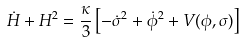<formula> <loc_0><loc_0><loc_500><loc_500>\dot { H } + H ^ { 2 } = \frac { \kappa } { 3 } \left [ - \dot { \sigma } ^ { 2 } + \dot { \phi } ^ { 2 } + V ( \phi , \sigma ) \right ]</formula> 